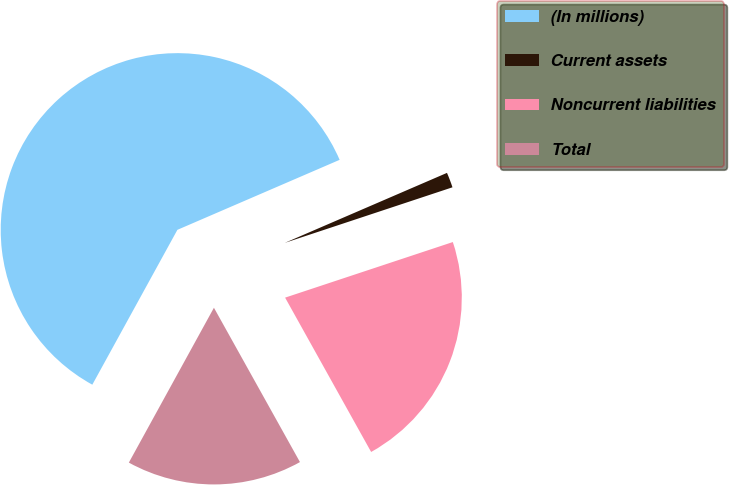<chart> <loc_0><loc_0><loc_500><loc_500><pie_chart><fcel>(In millions)<fcel>Current assets<fcel>Noncurrent liabilities<fcel>Total<nl><fcel>60.52%<fcel>1.39%<fcel>22.0%<fcel>16.09%<nl></chart> 